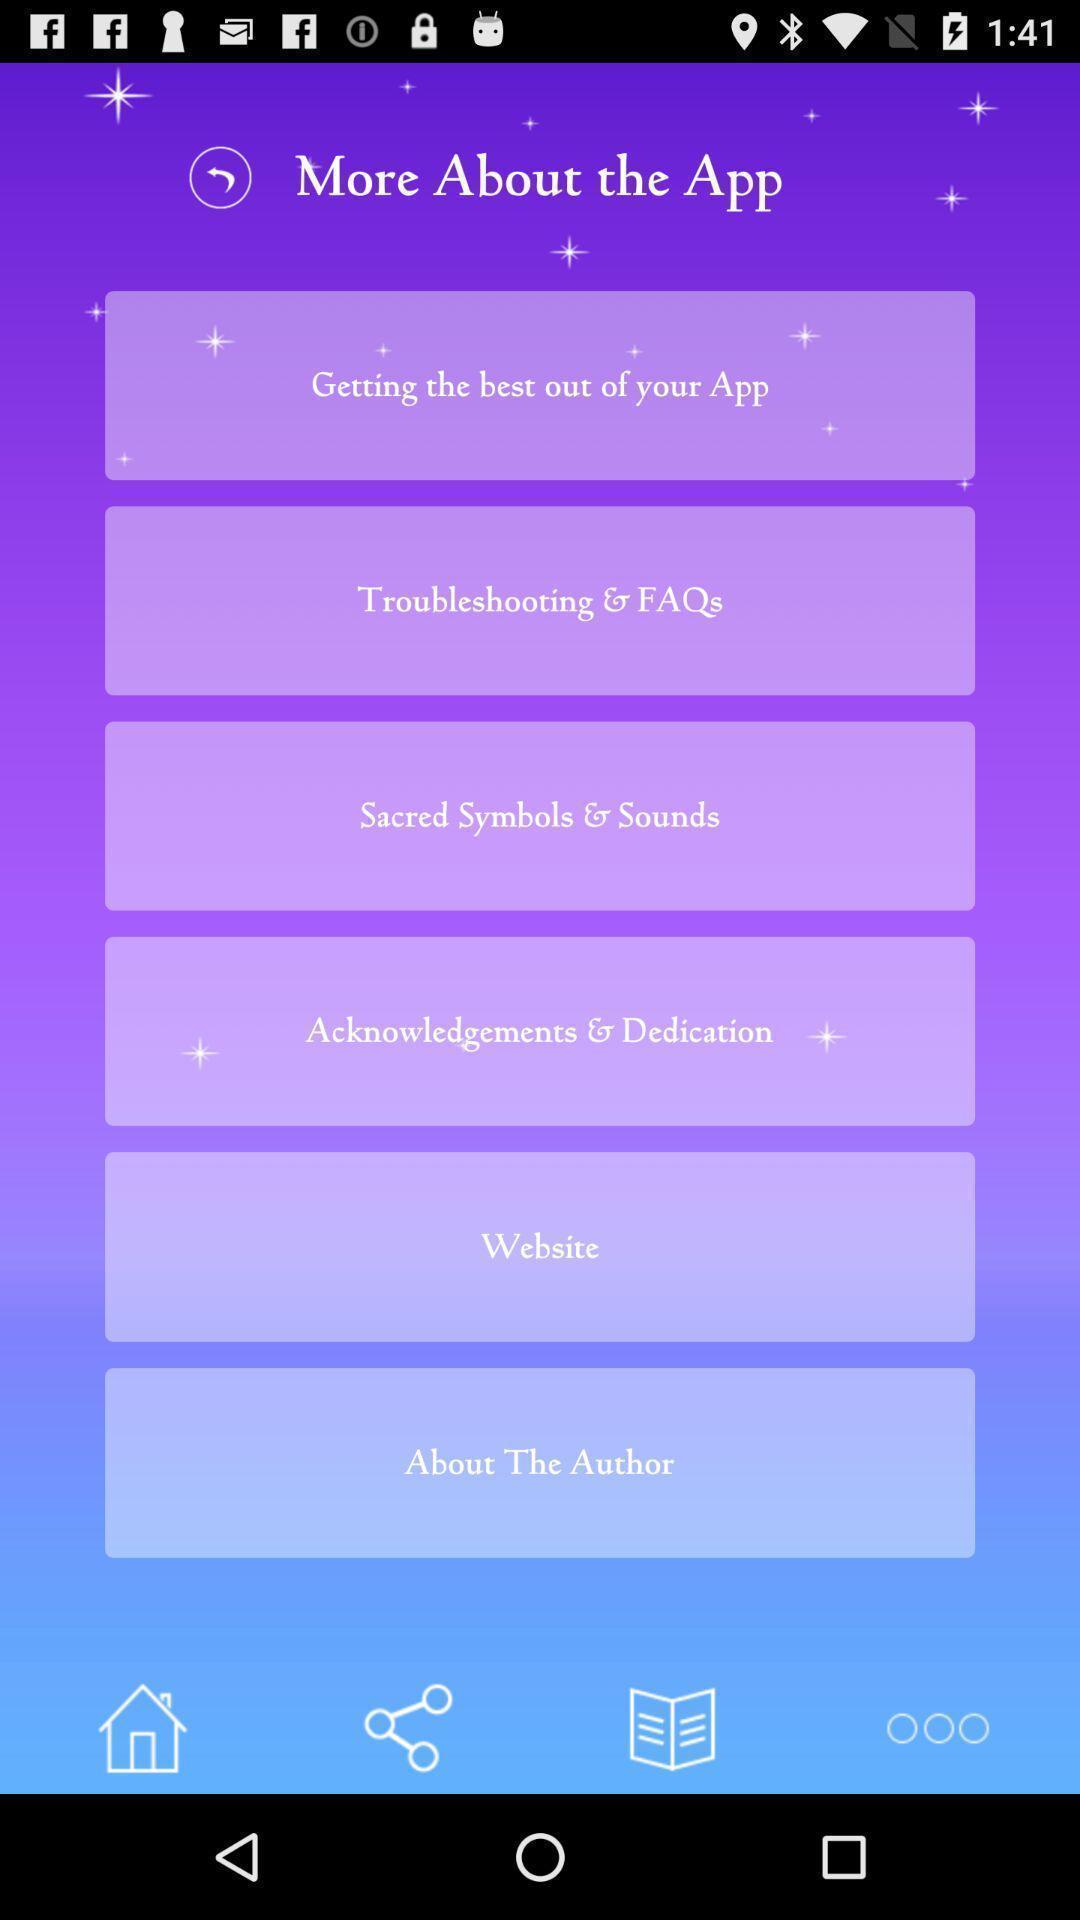Give me a summary of this screen capture. Page showing options about an app. 